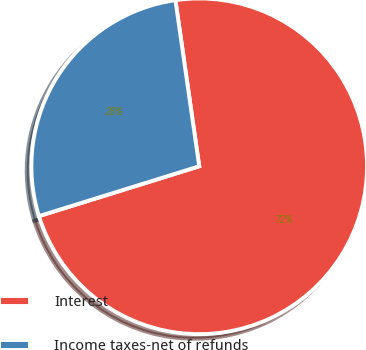Convert chart to OTSL. <chart><loc_0><loc_0><loc_500><loc_500><pie_chart><fcel>Interest<fcel>Income taxes-net of refunds<nl><fcel>72.47%<fcel>27.53%<nl></chart> 